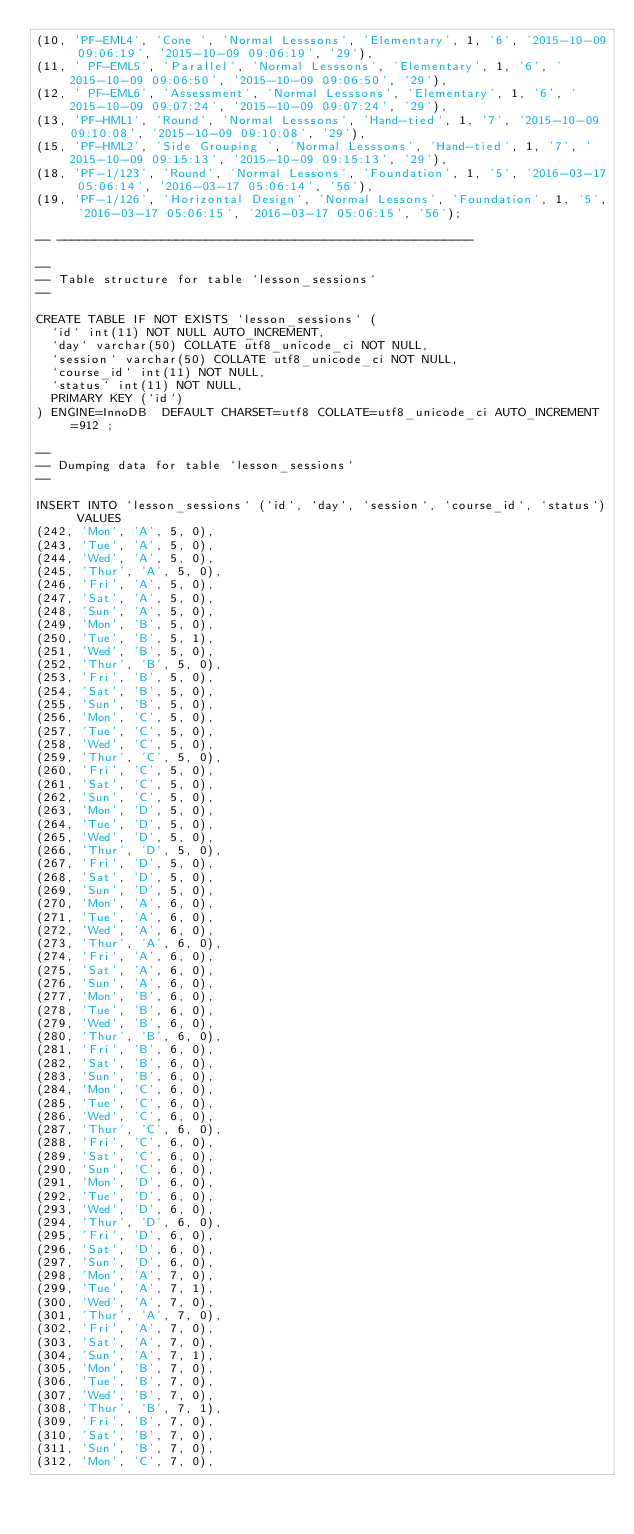<code> <loc_0><loc_0><loc_500><loc_500><_SQL_>(10, 'PF-EML4', 'Cone ', 'Normal Lesssons', 'Elementary', 1, '6', '2015-10-09 09:06:19', '2015-10-09 09:06:19', '29'),
(11, ' PF-EML5', 'Parallel', 'Normal Lesssons', 'Elementary', 1, '6', '2015-10-09 09:06:50', '2015-10-09 09:06:50', '29'),
(12, ' PF-EML6', 'Assessment', 'Normal Lesssons', 'Elementary', 1, '6', '2015-10-09 09:07:24', '2015-10-09 09:07:24', '29'),
(13, 'PF-HML1', 'Round', 'Normal Lesssons', 'Hand-tied', 1, '7', '2015-10-09 09:10:08', '2015-10-09 09:10:08', '29'),
(15, 'PF-HML2', 'Side Grouping ', 'Normal Lesssons', 'Hand-tied', 1, '7', '2015-10-09 09:15:13', '2015-10-09 09:15:13', '29'),
(18, 'PF-1/123', 'Round', 'Normal Lessons', 'Foundation', 1, '5', '2016-03-17 05:06:14', '2016-03-17 05:06:14', '56'),
(19, 'PF-1/126', 'Horizontal Design', 'Normal Lessons', 'Foundation', 1, '5', '2016-03-17 05:06:15', '2016-03-17 05:06:15', '56');

-- --------------------------------------------------------

--
-- Table structure for table `lesson_sessions`
--

CREATE TABLE IF NOT EXISTS `lesson_sessions` (
  `id` int(11) NOT NULL AUTO_INCREMENT,
  `day` varchar(50) COLLATE utf8_unicode_ci NOT NULL,
  `session` varchar(50) COLLATE utf8_unicode_ci NOT NULL,
  `course_id` int(11) NOT NULL,
  `status` int(11) NOT NULL,
  PRIMARY KEY (`id`)
) ENGINE=InnoDB  DEFAULT CHARSET=utf8 COLLATE=utf8_unicode_ci AUTO_INCREMENT=912 ;

--
-- Dumping data for table `lesson_sessions`
--

INSERT INTO `lesson_sessions` (`id`, `day`, `session`, `course_id`, `status`) VALUES
(242, 'Mon', 'A', 5, 0),
(243, 'Tue', 'A', 5, 0),
(244, 'Wed', 'A', 5, 0),
(245, 'Thur', 'A', 5, 0),
(246, 'Fri', 'A', 5, 0),
(247, 'Sat', 'A', 5, 0),
(248, 'Sun', 'A', 5, 0),
(249, 'Mon', 'B', 5, 0),
(250, 'Tue', 'B', 5, 1),
(251, 'Wed', 'B', 5, 0),
(252, 'Thur', 'B', 5, 0),
(253, 'Fri', 'B', 5, 0),
(254, 'Sat', 'B', 5, 0),
(255, 'Sun', 'B', 5, 0),
(256, 'Mon', 'C', 5, 0),
(257, 'Tue', 'C', 5, 0),
(258, 'Wed', 'C', 5, 0),
(259, 'Thur', 'C', 5, 0),
(260, 'Fri', 'C', 5, 0),
(261, 'Sat', 'C', 5, 0),
(262, 'Sun', 'C', 5, 0),
(263, 'Mon', 'D', 5, 0),
(264, 'Tue', 'D', 5, 0),
(265, 'Wed', 'D', 5, 0),
(266, 'Thur', 'D', 5, 0),
(267, 'Fri', 'D', 5, 0),
(268, 'Sat', 'D', 5, 0),
(269, 'Sun', 'D', 5, 0),
(270, 'Mon', 'A', 6, 0),
(271, 'Tue', 'A', 6, 0),
(272, 'Wed', 'A', 6, 0),
(273, 'Thur', 'A', 6, 0),
(274, 'Fri', 'A', 6, 0),
(275, 'Sat', 'A', 6, 0),
(276, 'Sun', 'A', 6, 0),
(277, 'Mon', 'B', 6, 0),
(278, 'Tue', 'B', 6, 0),
(279, 'Wed', 'B', 6, 0),
(280, 'Thur', 'B', 6, 0),
(281, 'Fri', 'B', 6, 0),
(282, 'Sat', 'B', 6, 0),
(283, 'Sun', 'B', 6, 0),
(284, 'Mon', 'C', 6, 0),
(285, 'Tue', 'C', 6, 0),
(286, 'Wed', 'C', 6, 0),
(287, 'Thur', 'C', 6, 0),
(288, 'Fri', 'C', 6, 0),
(289, 'Sat', 'C', 6, 0),
(290, 'Sun', 'C', 6, 0),
(291, 'Mon', 'D', 6, 0),
(292, 'Tue', 'D', 6, 0),
(293, 'Wed', 'D', 6, 0),
(294, 'Thur', 'D', 6, 0),
(295, 'Fri', 'D', 6, 0),
(296, 'Sat', 'D', 6, 0),
(297, 'Sun', 'D', 6, 0),
(298, 'Mon', 'A', 7, 0),
(299, 'Tue', 'A', 7, 1),
(300, 'Wed', 'A', 7, 0),
(301, 'Thur', 'A', 7, 0),
(302, 'Fri', 'A', 7, 0),
(303, 'Sat', 'A', 7, 0),
(304, 'Sun', 'A', 7, 1),
(305, 'Mon', 'B', 7, 0),
(306, 'Tue', 'B', 7, 0),
(307, 'Wed', 'B', 7, 0),
(308, 'Thur', 'B', 7, 1),
(309, 'Fri', 'B', 7, 0),
(310, 'Sat', 'B', 7, 0),
(311, 'Sun', 'B', 7, 0),
(312, 'Mon', 'C', 7, 0),</code> 